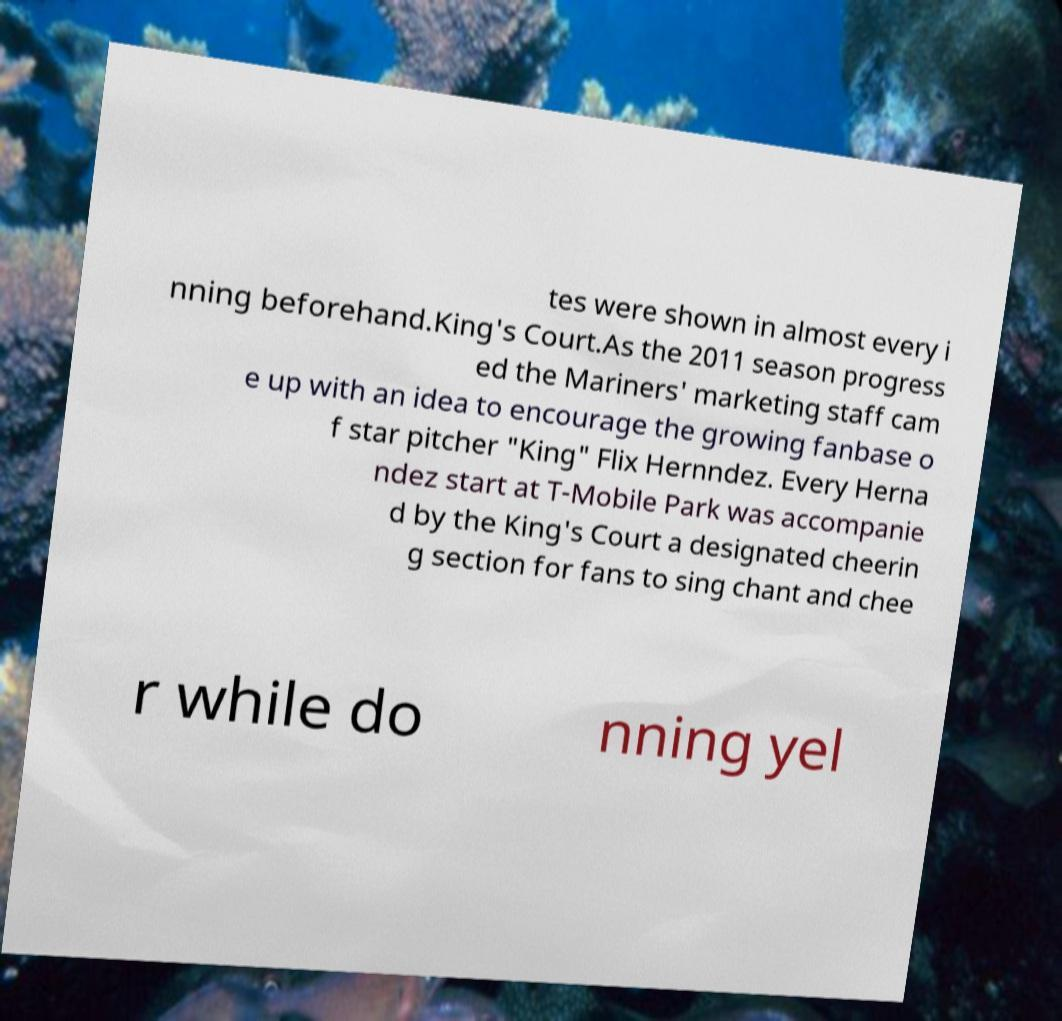Can you accurately transcribe the text from the provided image for me? tes were shown in almost every i nning beforehand.King's Court.As the 2011 season progress ed the Mariners' marketing staff cam e up with an idea to encourage the growing fanbase o f star pitcher "King" Flix Hernndez. Every Herna ndez start at T-Mobile Park was accompanie d by the King's Court a designated cheerin g section for fans to sing chant and chee r while do nning yel 